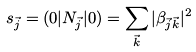Convert formula to latex. <formula><loc_0><loc_0><loc_500><loc_500>s _ { \vec { j } } = ( 0 | N _ { \vec { j } } | 0 ) = \sum _ { \vec { k } } | \beta _ { \vec { j } \vec { k } } | ^ { 2 }</formula> 